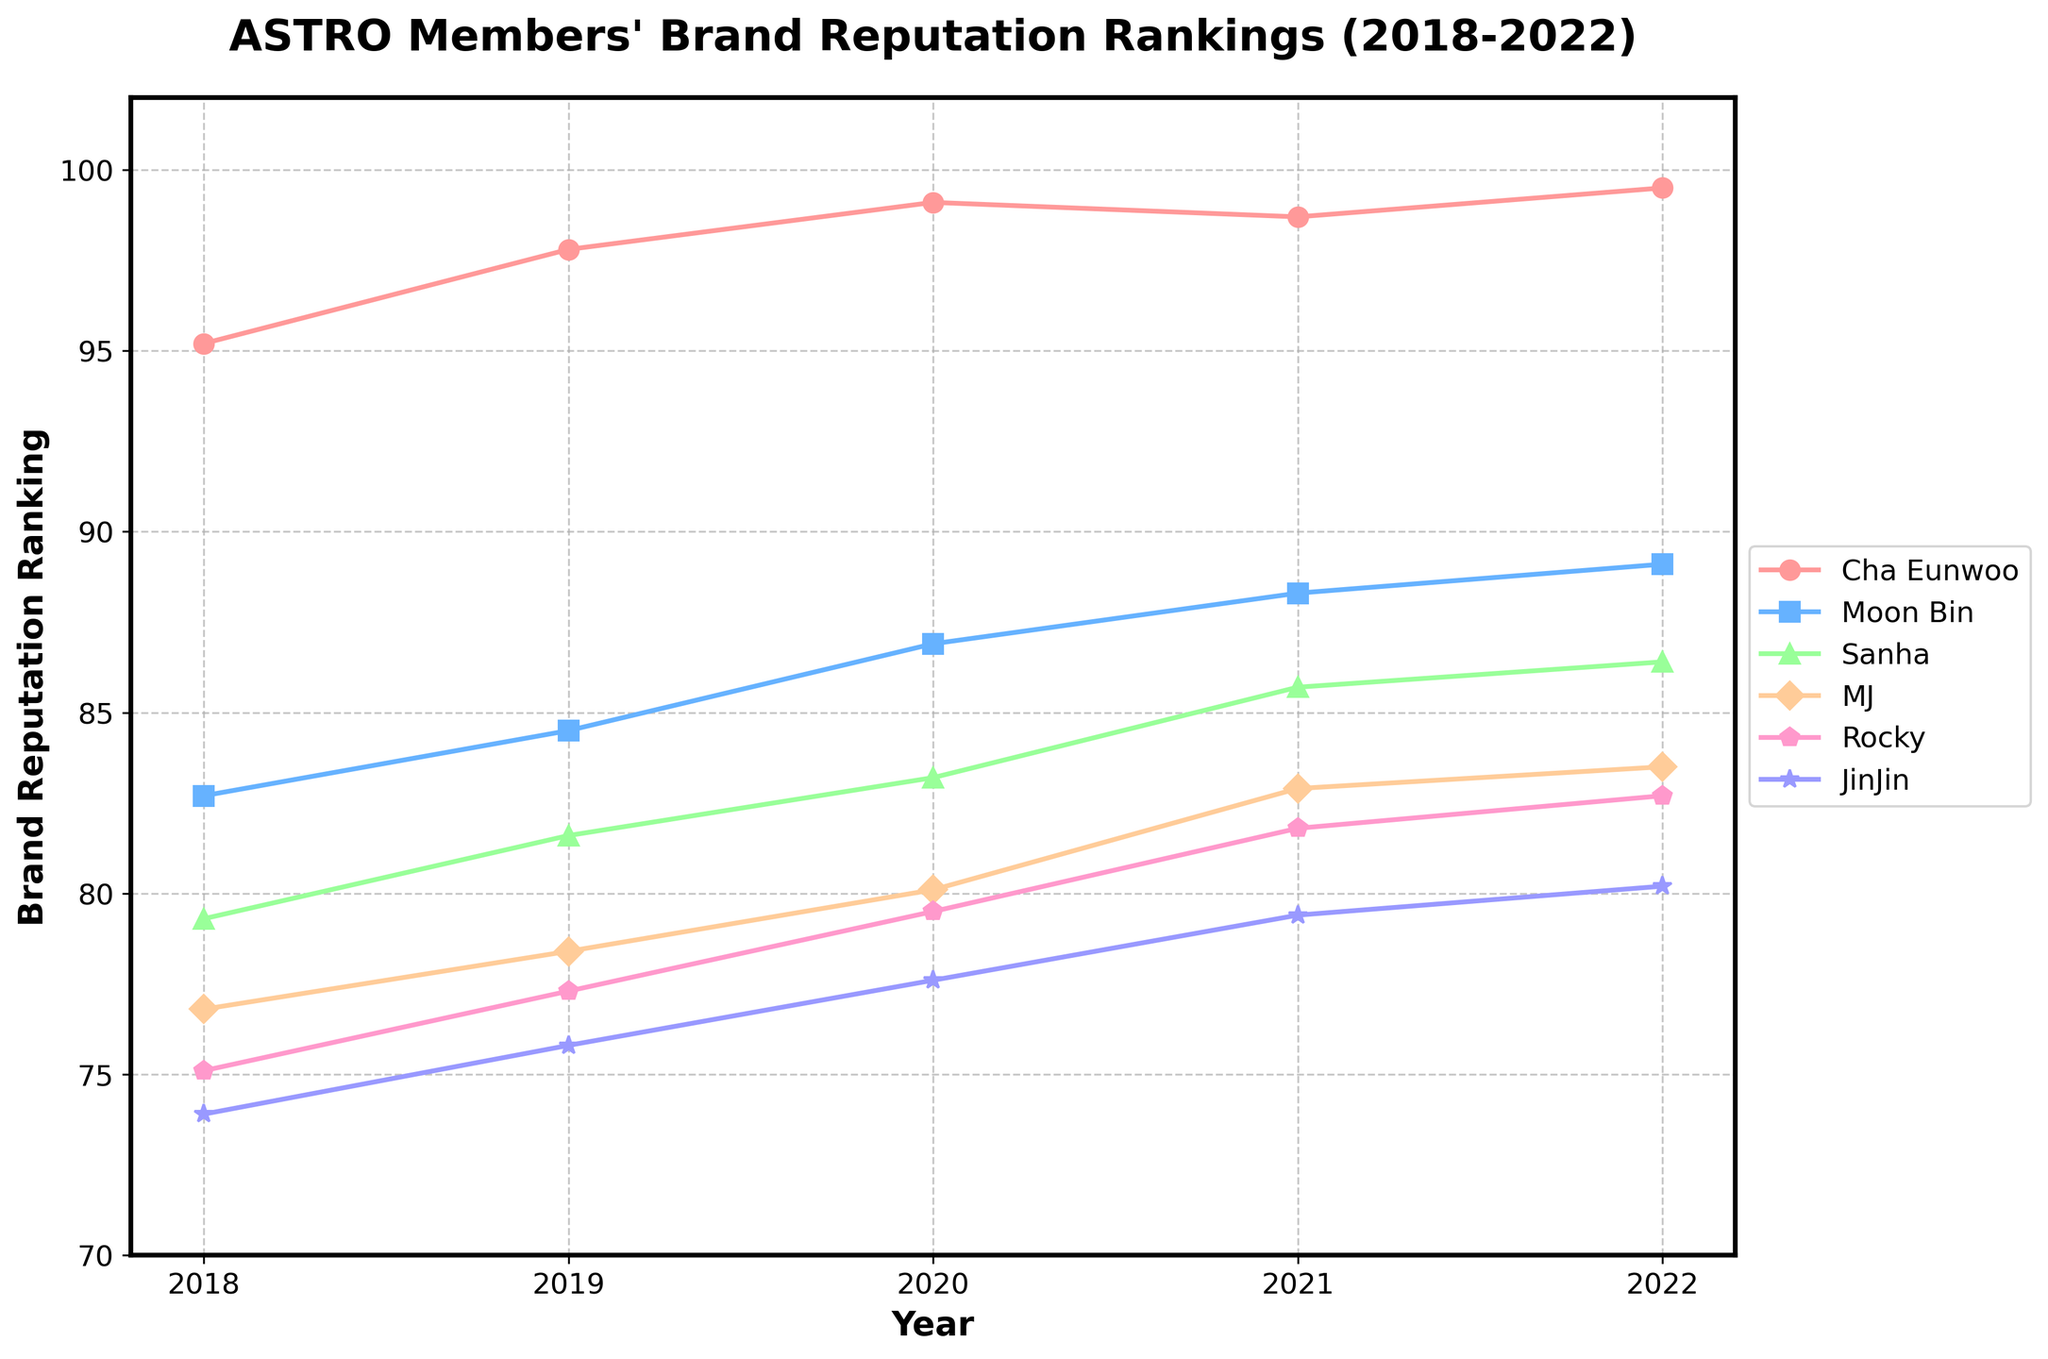What is the difference in Cha Eunwoo's brand reputation ranking between 2018 and 2022? To find the difference, subtract the 2018 value from the 2022 value. Difference = 99.5 - 95.2 = 4.3
Answer: 4.3 Which ASTRO member had the highest brand reputation ranking in 2021? By examining the line chart, we see that Cha Eunwoo's ranking in 2021 is the highest among the members, with a value of 98.7.
Answer: Cha Eunwoo How did Moon Bin's brand reputation ranking change from 2019 to 2022? To determine the change, calculate the difference between Moon Bin's ranking in 2022 and 2019. Change = 89.1 - 84.5 = 4.6
Answer: 4.6 Who had a more significant improvement in their brand reputation ranking from 2019 to 2020 - MJ or Rocky? Calculate the difference for both MJ and Rocky between these years. MJ: 80.1 - 78.4 = 1.7; Rocky: 79.5 - 77.3 = 2.2. Rocky had a larger improvement.
Answer: Rocky By how much did Sanha’s brand reputation increase from 2018 to 2020? Subtract Sanha's 2018 ranking from his 2020 ranking. Increase = 83.2 - 79.3 = 3.9
Answer: 3.9 Between 2021 and 2022, which ASTRO member showed the smallest increase in their brand reputation ranking? Calculate the difference for each member, then identify the smallest one. Cha Eunwoo: 99.5 - 98.7 = 0.8; Moon Bin: 89.1 - 88.3 = 0.8; Sanha: 86.4 - 85.7 = 0.7; MJ: 83.5 - 82.9 = 0.6; Rocky: 82.7 - 81.8 = 0.9; JinJin: 80.2 - 79.4 = 0.8. The smallest increase is for MJ (0.6).
Answer: MJ Compare the trend of JinJin's brand reputation ranking from 2018 to 2022 with that of MJ's. Which member had a steeper increase? Calculate the total increase for both. JinJin: 2022 - 2018 = 80.2 - 73.9 = 6.3; MJ: 2022 - 2018 = 83.5 - 76.8 = 6.7. MJ had a steeper increase.
Answer: MJ What is the average brand reputation ranking of Rocky over the given period? Sum up Rocky's rankings from 2018 to 2022 and divide by the number of years. (75.1 + 77.3 + 79.5 + 81.8 + 82.7) / 5 = 396.4 / 5 = 79.28
Answer: 79.28 Which member had a more stable trend in brand reputation from 2018 to 2022, JinJin or Sanha? Stability can be assessed by variations in their ranking: JinJin: (75.8 - 73.9) + (77.6 - 75.8) + (79.4 - 77.6) + (80.2 - 79.4) = 6.3; Sanha: (81.6 - 79.3) + (83.2 - 81.6) + (85.7 - 83.2) + (86.4 - 85.7) = 7.8. JinJin had a more stable trend with less overall variation.
Answer: JinJin 